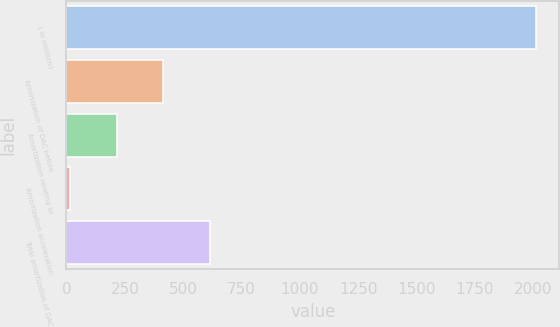Convert chart to OTSL. <chart><loc_0><loc_0><loc_500><loc_500><bar_chart><fcel>( in millions)<fcel>Amortization of DAC before<fcel>Amortization relating to<fcel>Amortization acceleration<fcel>Total amortization of DAC<nl><fcel>2010<fcel>414.8<fcel>215.4<fcel>16<fcel>614.2<nl></chart> 